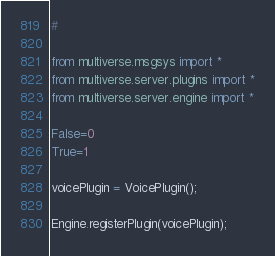Convert code to text. <code><loc_0><loc_0><loc_500><loc_500><_Python_>#

from multiverse.msgsys import *
from multiverse.server.plugins import *
from multiverse.server.engine import *

False=0
True=1

voicePlugin = VoicePlugin();

Engine.registerPlugin(voicePlugin);
</code> 